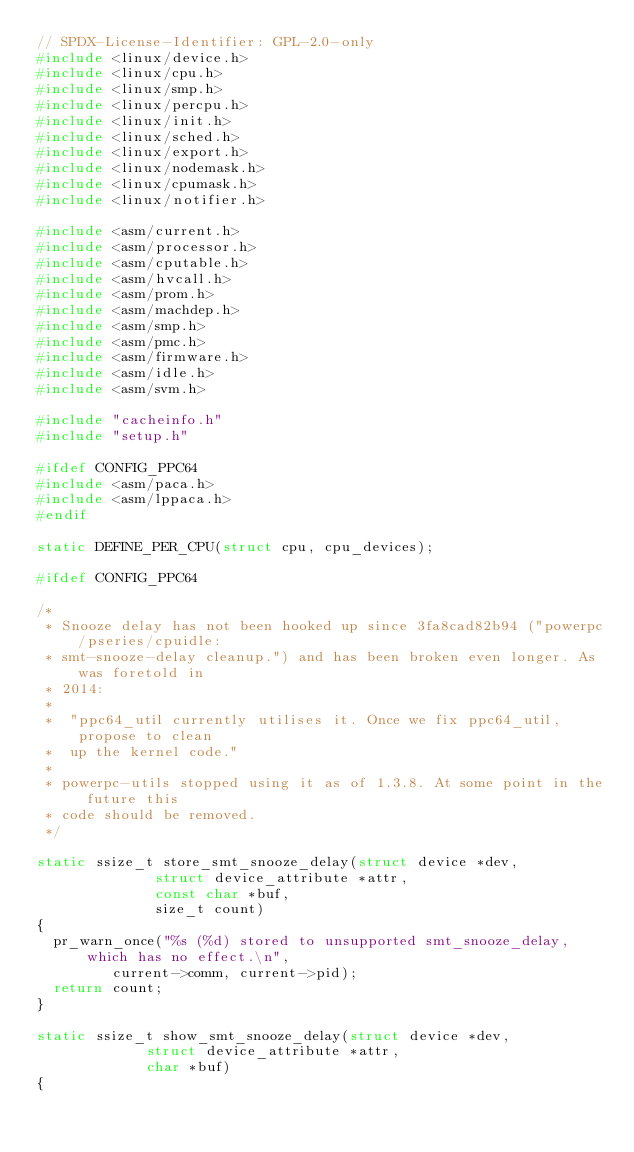<code> <loc_0><loc_0><loc_500><loc_500><_C_>// SPDX-License-Identifier: GPL-2.0-only
#include <linux/device.h>
#include <linux/cpu.h>
#include <linux/smp.h>
#include <linux/percpu.h>
#include <linux/init.h>
#include <linux/sched.h>
#include <linux/export.h>
#include <linux/nodemask.h>
#include <linux/cpumask.h>
#include <linux/notifier.h>

#include <asm/current.h>
#include <asm/processor.h>
#include <asm/cputable.h>
#include <asm/hvcall.h>
#include <asm/prom.h>
#include <asm/machdep.h>
#include <asm/smp.h>
#include <asm/pmc.h>
#include <asm/firmware.h>
#include <asm/idle.h>
#include <asm/svm.h>

#include "cacheinfo.h"
#include "setup.h"

#ifdef CONFIG_PPC64
#include <asm/paca.h>
#include <asm/lppaca.h>
#endif

static DEFINE_PER_CPU(struct cpu, cpu_devices);

#ifdef CONFIG_PPC64

/*
 * Snooze delay has not been hooked up since 3fa8cad82b94 ("powerpc/pseries/cpuidle:
 * smt-snooze-delay cleanup.") and has been broken even longer. As was foretold in
 * 2014:
 *
 *  "ppc64_util currently utilises it. Once we fix ppc64_util, propose to clean
 *  up the kernel code."
 *
 * powerpc-utils stopped using it as of 1.3.8. At some point in the future this
 * code should be removed.
 */

static ssize_t store_smt_snooze_delay(struct device *dev,
				      struct device_attribute *attr,
				      const char *buf,
				      size_t count)
{
	pr_warn_once("%s (%d) stored to unsupported smt_snooze_delay, which has no effect.\n",
		     current->comm, current->pid);
	return count;
}

static ssize_t show_smt_snooze_delay(struct device *dev,
				     struct device_attribute *attr,
				     char *buf)
{</code> 